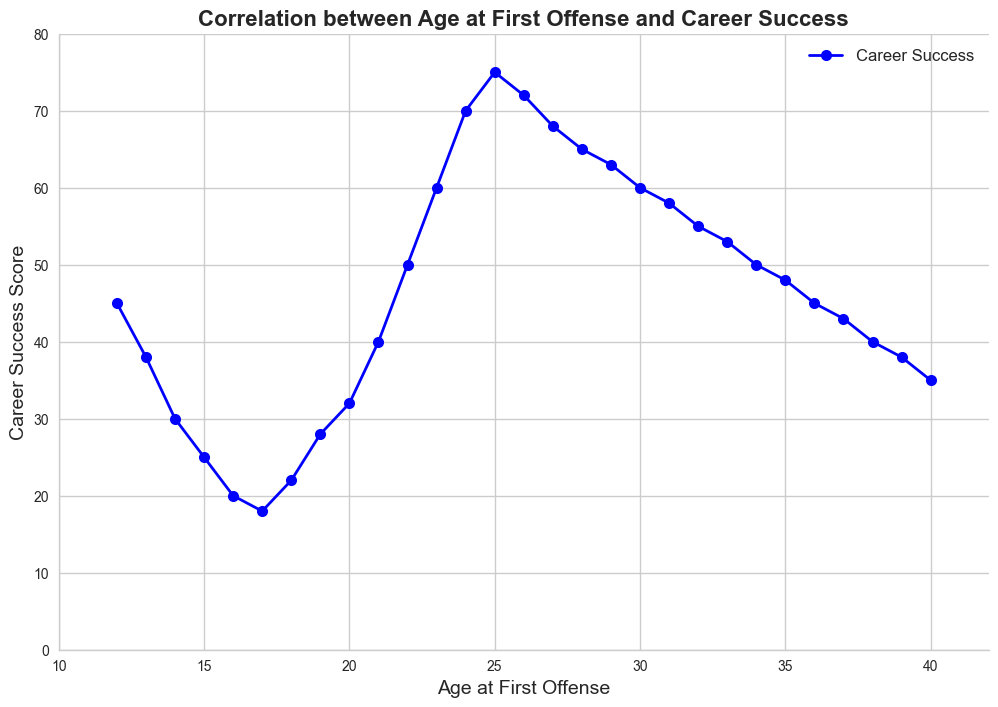What's the trend in Career Success Score as Age at First Offense increases? The plot shows a line with a downward trend initially for younger ages and an upward trend as age increases, indicating low career success for early offenses and improving success for later ages.
Answer: Downward then upward What is the Career Success Score for an individual who had their first offense at age 22? Locate age 22 on the x-axis and move up to the corresponding point on the line, which aligns with a score of 50 on the y-axis.
Answer: 50 At what age does the Career Success Score reach its highest value? The highest point on the Career Success Score line is found by locating the maximum y-value, which corresponds to age 25.
Answer: 25 Compare the Career Success Scores for first offenses at ages 15 and 30. Which is higher? Locate ages 15 and 30 on the x-axis and compare the y-values. Age 15 has a score of 25 and age 30 has a score of 60. The score at age 30 is higher.
Answer: Age 30 At what age does career success begin to show rapid improvement after a decline in early offenses? Observe the plot and identify the age where the Career Success Score starts to increase significantly after an initial decline. This occurs around age 18.
Answer: Age 18 How does the Career Success Score at age 18 compare to that at age 27? Identify the points for ages 18 and 27 on the plot and compare their y-values. Age 18 has a score of 22, while age 27 has a score of 68. The score at age 27 is significantly higher.
Answer: Age 27 By how much does the Career Success Score increase from age 20 to age 24? Locate the scores at ages 20 (32) and 24 (70), then compute the difference: 70 - 32 = 38.
Answer: 38 What is the average Career Success Score for the ages 12, 22, and 32? Identify scores at ages 12 (45), 22 (50), and 32 (55), then calculate the average: (45 + 50 + 55) / 3 = 150 / 3 = 50.
Answer: 50 Identify the age range with the lowest Career Success Scores. Observe the plot to identify the age range where the Career Success line is at its lowest, which is between ages 16 and 18.
Answer: 16-18 What's the Career Success Score trend from age 29 to age 39? Observe the Career Success Score line from ages 29 to 39. It shows a gradual decrease from 63 to 38.
Answer: Gradual decrease 